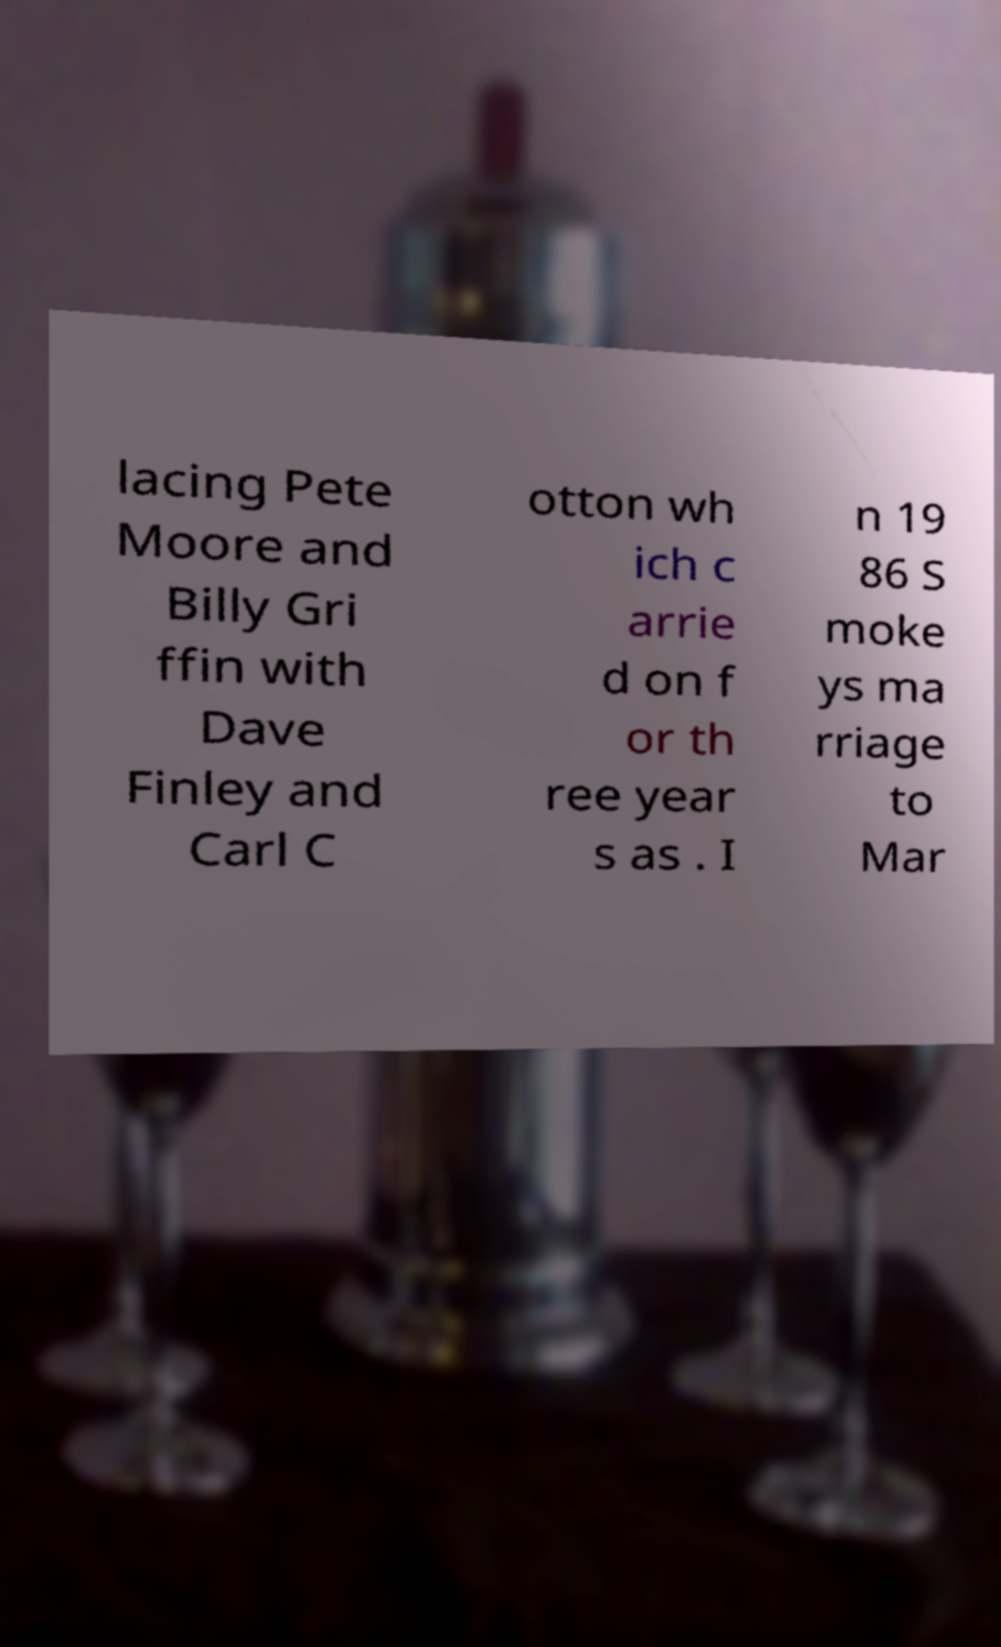What messages or text are displayed in this image? I need them in a readable, typed format. lacing Pete Moore and Billy Gri ffin with Dave Finley and Carl C otton wh ich c arrie d on f or th ree year s as . I n 19 86 S moke ys ma rriage to Mar 